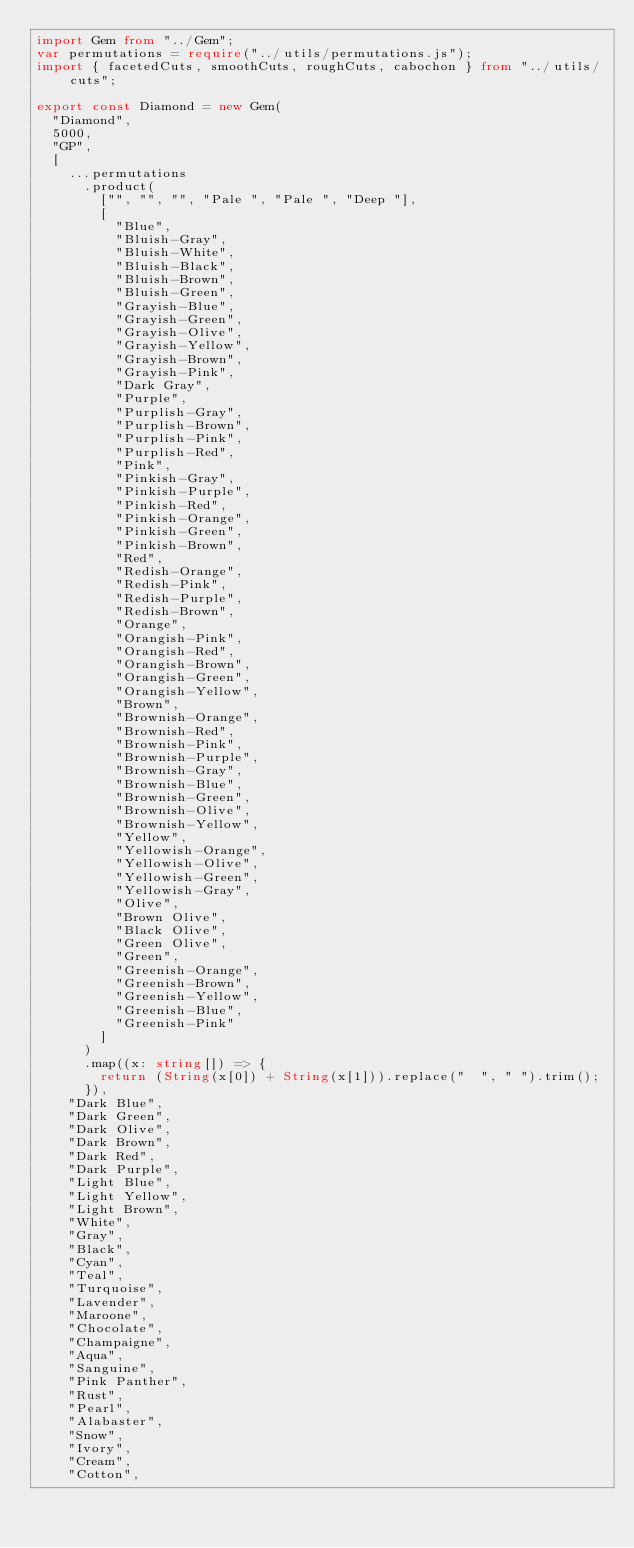<code> <loc_0><loc_0><loc_500><loc_500><_TypeScript_>import Gem from "../Gem";
var permutations = require("../utils/permutations.js");
import { facetedCuts, smoothCuts, roughCuts, cabochon } from "../utils/cuts";

export const Diamond = new Gem(
  "Diamond",
  5000,
  "GP",
  [
    ...permutations
      .product(
        ["", "", "", "Pale ", "Pale ", "Deep "],
        [
          "Blue",
          "Bluish-Gray",
          "Bluish-White",
          "Bluish-Black",
          "Bluish-Brown",
          "Bluish-Green",
          "Grayish-Blue",
          "Grayish-Green",
          "Grayish-Olive",
          "Grayish-Yellow",
          "Grayish-Brown",
          "Grayish-Pink",
          "Dark Gray",
          "Purple",
          "Purplish-Gray",
          "Purplish-Brown",
          "Purplish-Pink",
          "Purplish-Red",
          "Pink",
          "Pinkish-Gray",
          "Pinkish-Purple",
          "Pinkish-Red",
          "Pinkish-Orange",
          "Pinkish-Green",
          "Pinkish-Brown",
          "Red",
          "Redish-Orange",
          "Redish-Pink",
          "Redish-Purple",
          "Redish-Brown",
          "Orange",
          "Orangish-Pink",
          "Orangish-Red",
          "Orangish-Brown",
          "Orangish-Green",
          "Orangish-Yellow",
          "Brown",
          "Brownish-Orange",
          "Brownish-Red",
          "Brownish-Pink",
          "Brownish-Purple",
          "Brownish-Gray",
          "Brownish-Blue",
          "Brownish-Green",
          "Brownish-Olive",
          "Brownish-Yellow",
          "Yellow",
          "Yellowish-Orange",
          "Yellowish-Olive",
          "Yellowish-Green",
          "Yellowish-Gray",
          "Olive",
          "Brown Olive",
          "Black Olive",
          "Green Olive",
          "Green",
          "Greenish-Orange",
          "Greenish-Brown",
          "Greenish-Yellow",
          "Greenish-Blue",
          "Greenish-Pink"
        ]
      )
      .map((x: string[]) => {
        return (String(x[0]) + String(x[1])).replace("  ", " ").trim();
      }),
    "Dark Blue",
    "Dark Green",
    "Dark Olive",
    "Dark Brown",
    "Dark Red",
    "Dark Purple",
    "Light Blue",
    "Light Yellow",
    "Light Brown",
    "White",
    "Gray",
    "Black",
    "Cyan",
    "Teal",
    "Turquoise",
    "Lavender",
    "Maroone",
    "Chocolate",
    "Champaigne",
    "Aqua",
    "Sanguine",
    "Pink Panther",
    "Rust",
    "Pearl",
    "Alabaster",
    "Snow",
    "Ivory",
    "Cream",
    "Cotton",</code> 